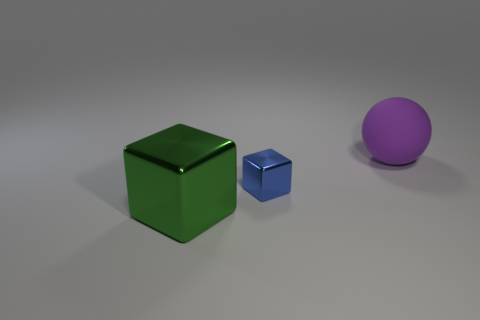What could the arrangement and selection of these objects tell us about the purpose of this image? The arrangement of a large green cube, a smaller blue cube, and a large purple sphere might suggest a study in color theory or an exercise in 3D modeling. The selection of bright, distinct colors helps to emphasize the differences between the objects. Their placement against a neutral background can highlight their individual properties and could be used to illustrate concepts such as size comparison, spatial relationships, or simply serve as a visual composition in graphic design or art. 